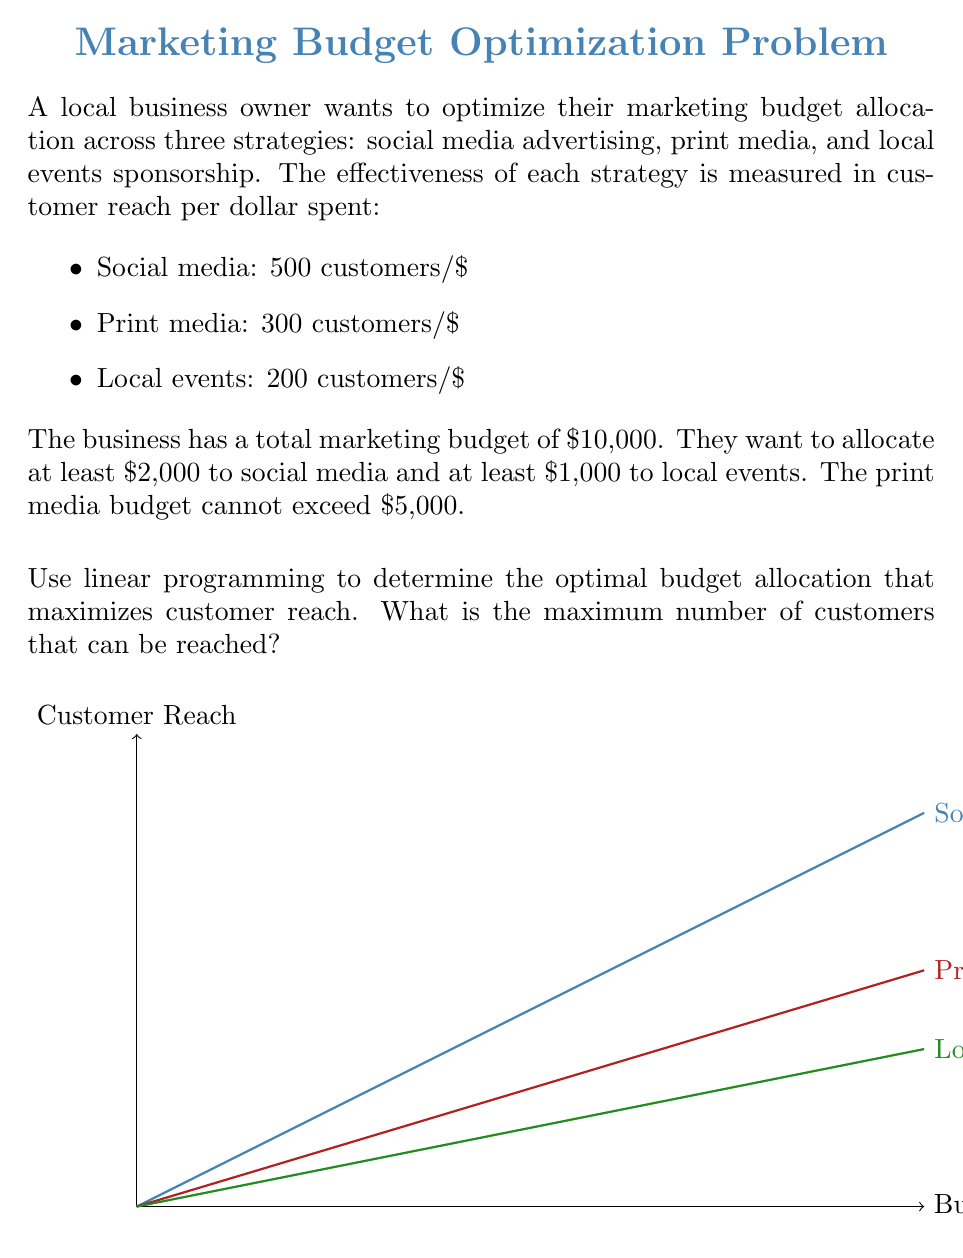Solve this math problem. Let's solve this step-by-step using linear programming:

1) Define variables:
   $x$ = budget for social media
   $y$ = budget for print media
   $z$ = budget for local events

2) Objective function (maximize customer reach):
   $$\text{Maximize } 500x + 300y + 200z$$

3) Constraints:
   Total budget: $x + y + z \leq 10000$
   Social media minimum: $x \geq 2000$
   Local events minimum: $z \geq 1000$
   Print media maximum: $y \leq 5000$
   Non-negativity: $x, y, z \geq 0$

4) Set up the linear program:
   $$\begin{align*}
   \text{Maximize: } & 500x + 300y + 200z \\
   \text{Subject to: } & x + y + z \leq 10000 \\
   & x \geq 2000 \\
   & z \geq 1000 \\
   & y \leq 5000 \\
   & x, y, z \geq 0
   \end{align*}$$

5) Solve using the simplex method or a linear programming solver. The optimal solution is:
   $x = 4000$, $y = 5000$, $z = 1000$

6) Calculate the maximum customer reach:
   $500(4000) + 300(5000) + 200(1000) = 3,700,000$

Therefore, the optimal budget allocation is $4,000 for social media, $5,000 for print media, and $1,000 for local events, reaching a maximum of 3,700,000 customers.
Answer: 3,700,000 customers 